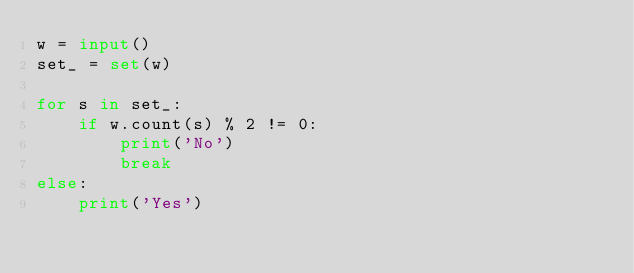<code> <loc_0><loc_0><loc_500><loc_500><_Python_>w = input()
set_ = set(w)

for s in set_:
    if w.count(s) % 2 != 0:
        print('No')
        break
else:
    print('Yes')</code> 